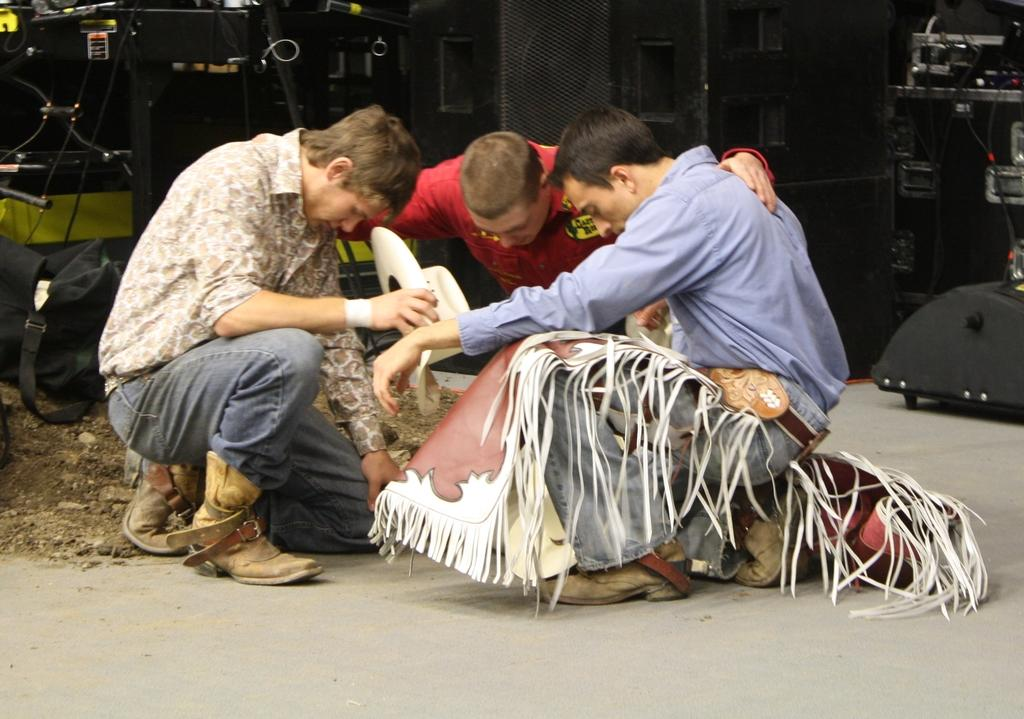How many people are sitting in the image? There are three people sitting in the image. What can be seen near the people? Speakers are visible in the image. What else can be seen in the background of the image? There are electronic devices in the background of the image. What type of cave can be seen in the background of the image? There is no cave present in the image; it features three people sitting and speakers. 